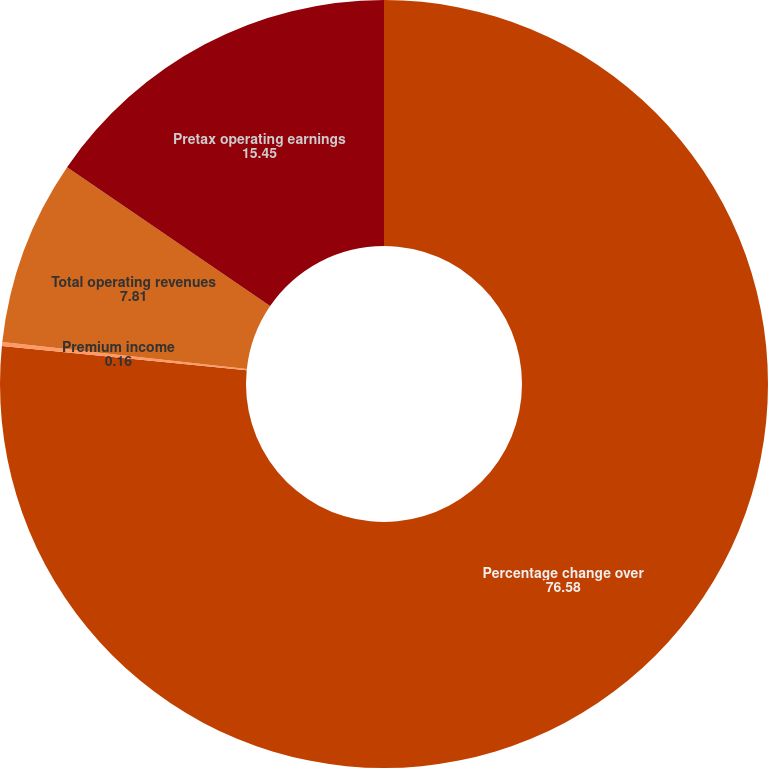<chart> <loc_0><loc_0><loc_500><loc_500><pie_chart><fcel>Percentage change over<fcel>Premium income<fcel>Total operating revenues<fcel>Pretax operating earnings<nl><fcel>76.58%<fcel>0.16%<fcel>7.81%<fcel>15.45%<nl></chart> 